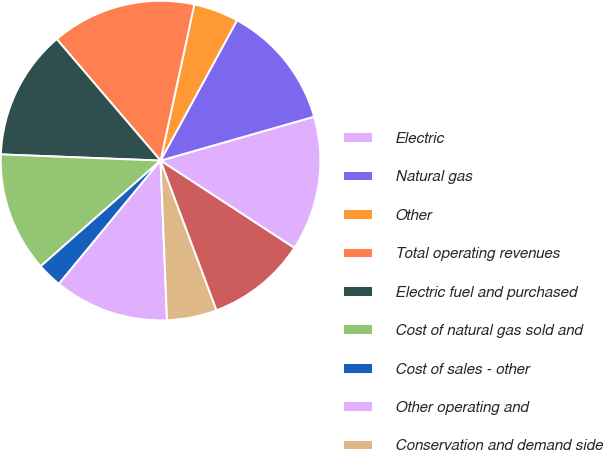Convert chart. <chart><loc_0><loc_0><loc_500><loc_500><pie_chart><fcel>Electric<fcel>Natural gas<fcel>Other<fcel>Total operating revenues<fcel>Electric fuel and purchased<fcel>Cost of natural gas sold and<fcel>Cost of sales - other<fcel>Other operating and<fcel>Conservation and demand side<fcel>Depreciation and amortization<nl><fcel>13.64%<fcel>12.63%<fcel>4.55%<fcel>14.65%<fcel>13.13%<fcel>12.12%<fcel>2.53%<fcel>11.62%<fcel>5.05%<fcel>10.1%<nl></chart> 